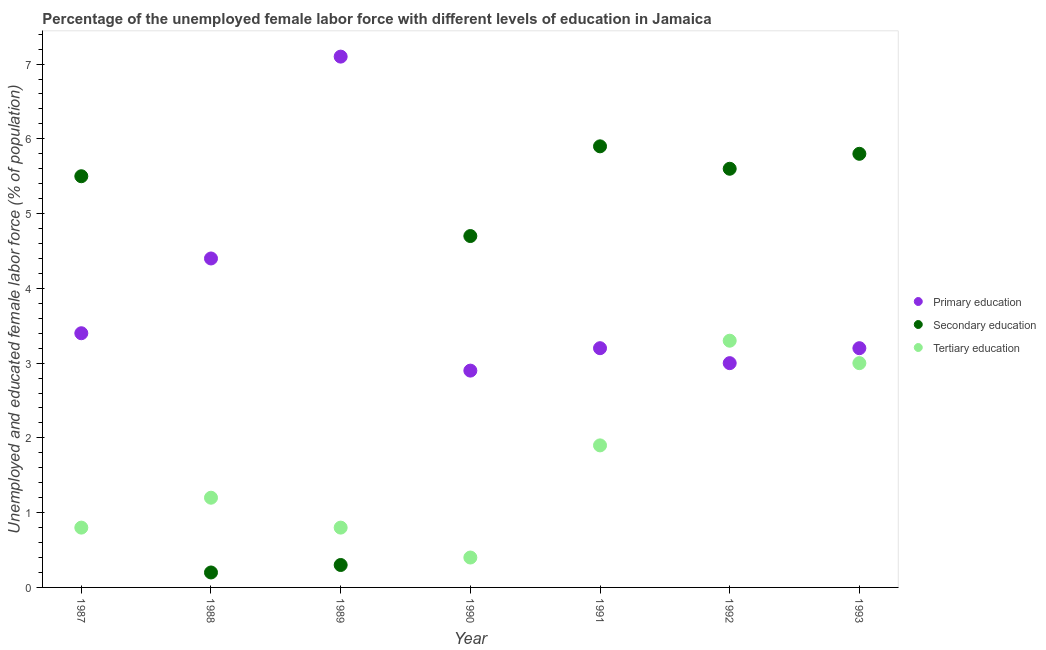How many different coloured dotlines are there?
Provide a short and direct response. 3. What is the percentage of female labor force who received tertiary education in 1992?
Your response must be concise. 3.3. Across all years, what is the maximum percentage of female labor force who received secondary education?
Your answer should be compact. 5.9. Across all years, what is the minimum percentage of female labor force who received primary education?
Provide a short and direct response. 2.9. What is the total percentage of female labor force who received tertiary education in the graph?
Make the answer very short. 11.4. What is the difference between the percentage of female labor force who received primary education in 1988 and that in 1989?
Keep it short and to the point. -2.7. What is the difference between the percentage of female labor force who received primary education in 1990 and the percentage of female labor force who received tertiary education in 1992?
Give a very brief answer. -0.4. What is the average percentage of female labor force who received primary education per year?
Your answer should be very brief. 3.89. In the year 1990, what is the difference between the percentage of female labor force who received primary education and percentage of female labor force who received secondary education?
Provide a succinct answer. -1.8. In how many years, is the percentage of female labor force who received primary education greater than 1.6 %?
Ensure brevity in your answer.  7. What is the ratio of the percentage of female labor force who received secondary education in 1988 to that in 1993?
Your answer should be compact. 0.03. What is the difference between the highest and the second highest percentage of female labor force who received secondary education?
Provide a short and direct response. 0.1. What is the difference between the highest and the lowest percentage of female labor force who received tertiary education?
Offer a very short reply. 2.9. Is it the case that in every year, the sum of the percentage of female labor force who received primary education and percentage of female labor force who received secondary education is greater than the percentage of female labor force who received tertiary education?
Offer a very short reply. Yes. Does the percentage of female labor force who received tertiary education monotonically increase over the years?
Keep it short and to the point. No. Is the percentage of female labor force who received secondary education strictly greater than the percentage of female labor force who received primary education over the years?
Provide a short and direct response. No. How many dotlines are there?
Your answer should be very brief. 3. Are the values on the major ticks of Y-axis written in scientific E-notation?
Keep it short and to the point. No. Where does the legend appear in the graph?
Provide a short and direct response. Center right. How many legend labels are there?
Your answer should be very brief. 3. How are the legend labels stacked?
Your answer should be compact. Vertical. What is the title of the graph?
Your answer should be compact. Percentage of the unemployed female labor force with different levels of education in Jamaica. Does "Agricultural raw materials" appear as one of the legend labels in the graph?
Ensure brevity in your answer.  No. What is the label or title of the X-axis?
Make the answer very short. Year. What is the label or title of the Y-axis?
Provide a short and direct response. Unemployed and educated female labor force (% of population). What is the Unemployed and educated female labor force (% of population) of Primary education in 1987?
Make the answer very short. 3.4. What is the Unemployed and educated female labor force (% of population) in Secondary education in 1987?
Offer a very short reply. 5.5. What is the Unemployed and educated female labor force (% of population) of Tertiary education in 1987?
Provide a short and direct response. 0.8. What is the Unemployed and educated female labor force (% of population) of Primary education in 1988?
Provide a short and direct response. 4.4. What is the Unemployed and educated female labor force (% of population) in Secondary education in 1988?
Provide a succinct answer. 0.2. What is the Unemployed and educated female labor force (% of population) of Tertiary education in 1988?
Ensure brevity in your answer.  1.2. What is the Unemployed and educated female labor force (% of population) in Primary education in 1989?
Give a very brief answer. 7.1. What is the Unemployed and educated female labor force (% of population) of Secondary education in 1989?
Your answer should be compact. 0.3. What is the Unemployed and educated female labor force (% of population) in Tertiary education in 1989?
Make the answer very short. 0.8. What is the Unemployed and educated female labor force (% of population) in Primary education in 1990?
Ensure brevity in your answer.  2.9. What is the Unemployed and educated female labor force (% of population) of Secondary education in 1990?
Offer a terse response. 4.7. What is the Unemployed and educated female labor force (% of population) of Tertiary education in 1990?
Offer a terse response. 0.4. What is the Unemployed and educated female labor force (% of population) in Primary education in 1991?
Give a very brief answer. 3.2. What is the Unemployed and educated female labor force (% of population) of Secondary education in 1991?
Provide a succinct answer. 5.9. What is the Unemployed and educated female labor force (% of population) in Tertiary education in 1991?
Make the answer very short. 1.9. What is the Unemployed and educated female labor force (% of population) in Secondary education in 1992?
Provide a short and direct response. 5.6. What is the Unemployed and educated female labor force (% of population) in Tertiary education in 1992?
Your answer should be compact. 3.3. What is the Unemployed and educated female labor force (% of population) of Primary education in 1993?
Your answer should be very brief. 3.2. What is the Unemployed and educated female labor force (% of population) in Secondary education in 1993?
Your answer should be compact. 5.8. Across all years, what is the maximum Unemployed and educated female labor force (% of population) of Primary education?
Give a very brief answer. 7.1. Across all years, what is the maximum Unemployed and educated female labor force (% of population) in Secondary education?
Your answer should be very brief. 5.9. Across all years, what is the maximum Unemployed and educated female labor force (% of population) in Tertiary education?
Give a very brief answer. 3.3. Across all years, what is the minimum Unemployed and educated female labor force (% of population) of Primary education?
Your answer should be very brief. 2.9. Across all years, what is the minimum Unemployed and educated female labor force (% of population) in Secondary education?
Provide a succinct answer. 0.2. Across all years, what is the minimum Unemployed and educated female labor force (% of population) in Tertiary education?
Offer a terse response. 0.4. What is the total Unemployed and educated female labor force (% of population) of Primary education in the graph?
Make the answer very short. 27.2. What is the total Unemployed and educated female labor force (% of population) of Secondary education in the graph?
Make the answer very short. 28. What is the total Unemployed and educated female labor force (% of population) of Tertiary education in the graph?
Your answer should be compact. 11.4. What is the difference between the Unemployed and educated female labor force (% of population) of Primary education in 1987 and that in 1988?
Provide a succinct answer. -1. What is the difference between the Unemployed and educated female labor force (% of population) in Primary education in 1987 and that in 1989?
Provide a succinct answer. -3.7. What is the difference between the Unemployed and educated female labor force (% of population) in Secondary education in 1987 and that in 1989?
Provide a succinct answer. 5.2. What is the difference between the Unemployed and educated female labor force (% of population) of Tertiary education in 1987 and that in 1989?
Give a very brief answer. 0. What is the difference between the Unemployed and educated female labor force (% of population) of Tertiary education in 1987 and that in 1990?
Your answer should be very brief. 0.4. What is the difference between the Unemployed and educated female labor force (% of population) of Primary education in 1987 and that in 1991?
Give a very brief answer. 0.2. What is the difference between the Unemployed and educated female labor force (% of population) of Secondary education in 1987 and that in 1992?
Your answer should be compact. -0.1. What is the difference between the Unemployed and educated female labor force (% of population) in Tertiary education in 1987 and that in 1992?
Keep it short and to the point. -2.5. What is the difference between the Unemployed and educated female labor force (% of population) of Primary education in 1987 and that in 1993?
Your answer should be compact. 0.2. What is the difference between the Unemployed and educated female labor force (% of population) of Primary education in 1988 and that in 1989?
Offer a terse response. -2.7. What is the difference between the Unemployed and educated female labor force (% of population) in Tertiary education in 1988 and that in 1989?
Your answer should be compact. 0.4. What is the difference between the Unemployed and educated female labor force (% of population) of Primary education in 1988 and that in 1991?
Ensure brevity in your answer.  1.2. What is the difference between the Unemployed and educated female labor force (% of population) in Secondary education in 1988 and that in 1991?
Ensure brevity in your answer.  -5.7. What is the difference between the Unemployed and educated female labor force (% of population) in Primary education in 1988 and that in 1992?
Your answer should be compact. 1.4. What is the difference between the Unemployed and educated female labor force (% of population) in Secondary education in 1988 and that in 1992?
Your response must be concise. -5.4. What is the difference between the Unemployed and educated female labor force (% of population) in Secondary education in 1988 and that in 1993?
Offer a terse response. -5.6. What is the difference between the Unemployed and educated female labor force (% of population) of Tertiary education in 1988 and that in 1993?
Your answer should be compact. -1.8. What is the difference between the Unemployed and educated female labor force (% of population) in Primary education in 1989 and that in 1990?
Make the answer very short. 4.2. What is the difference between the Unemployed and educated female labor force (% of population) of Secondary education in 1989 and that in 1990?
Provide a short and direct response. -4.4. What is the difference between the Unemployed and educated female labor force (% of population) in Primary education in 1989 and that in 1991?
Provide a succinct answer. 3.9. What is the difference between the Unemployed and educated female labor force (% of population) in Primary education in 1989 and that in 1992?
Ensure brevity in your answer.  4.1. What is the difference between the Unemployed and educated female labor force (% of population) in Secondary education in 1989 and that in 1993?
Ensure brevity in your answer.  -5.5. What is the difference between the Unemployed and educated female labor force (% of population) in Tertiary education in 1989 and that in 1993?
Give a very brief answer. -2.2. What is the difference between the Unemployed and educated female labor force (% of population) of Secondary education in 1990 and that in 1991?
Your answer should be compact. -1.2. What is the difference between the Unemployed and educated female labor force (% of population) of Primary education in 1990 and that in 1992?
Offer a very short reply. -0.1. What is the difference between the Unemployed and educated female labor force (% of population) in Secondary education in 1990 and that in 1992?
Offer a terse response. -0.9. What is the difference between the Unemployed and educated female labor force (% of population) of Tertiary education in 1990 and that in 1992?
Keep it short and to the point. -2.9. What is the difference between the Unemployed and educated female labor force (% of population) of Secondary education in 1990 and that in 1993?
Offer a terse response. -1.1. What is the difference between the Unemployed and educated female labor force (% of population) of Primary education in 1991 and that in 1992?
Offer a very short reply. 0.2. What is the difference between the Unemployed and educated female labor force (% of population) of Tertiary education in 1991 and that in 1992?
Your answer should be compact. -1.4. What is the difference between the Unemployed and educated female labor force (% of population) of Tertiary education in 1991 and that in 1993?
Give a very brief answer. -1.1. What is the difference between the Unemployed and educated female labor force (% of population) of Primary education in 1992 and that in 1993?
Offer a terse response. -0.2. What is the difference between the Unemployed and educated female labor force (% of population) of Secondary education in 1992 and that in 1993?
Provide a short and direct response. -0.2. What is the difference between the Unemployed and educated female labor force (% of population) in Primary education in 1987 and the Unemployed and educated female labor force (% of population) in Tertiary education in 1988?
Ensure brevity in your answer.  2.2. What is the difference between the Unemployed and educated female labor force (% of population) of Primary education in 1987 and the Unemployed and educated female labor force (% of population) of Tertiary education in 1989?
Offer a terse response. 2.6. What is the difference between the Unemployed and educated female labor force (% of population) of Secondary education in 1987 and the Unemployed and educated female labor force (% of population) of Tertiary education in 1989?
Offer a terse response. 4.7. What is the difference between the Unemployed and educated female labor force (% of population) of Primary education in 1987 and the Unemployed and educated female labor force (% of population) of Tertiary education in 1990?
Give a very brief answer. 3. What is the difference between the Unemployed and educated female labor force (% of population) of Primary education in 1987 and the Unemployed and educated female labor force (% of population) of Secondary education in 1991?
Your answer should be compact. -2.5. What is the difference between the Unemployed and educated female labor force (% of population) in Primary education in 1987 and the Unemployed and educated female labor force (% of population) in Secondary education in 1993?
Your answer should be compact. -2.4. What is the difference between the Unemployed and educated female labor force (% of population) in Primary education in 1987 and the Unemployed and educated female labor force (% of population) in Tertiary education in 1993?
Keep it short and to the point. 0.4. What is the difference between the Unemployed and educated female labor force (% of population) of Secondary education in 1987 and the Unemployed and educated female labor force (% of population) of Tertiary education in 1993?
Give a very brief answer. 2.5. What is the difference between the Unemployed and educated female labor force (% of population) in Primary education in 1988 and the Unemployed and educated female labor force (% of population) in Secondary education in 1989?
Offer a very short reply. 4.1. What is the difference between the Unemployed and educated female labor force (% of population) of Primary education in 1988 and the Unemployed and educated female labor force (% of population) of Tertiary education in 1990?
Keep it short and to the point. 4. What is the difference between the Unemployed and educated female labor force (% of population) of Secondary education in 1988 and the Unemployed and educated female labor force (% of population) of Tertiary education in 1990?
Offer a very short reply. -0.2. What is the difference between the Unemployed and educated female labor force (% of population) in Primary education in 1988 and the Unemployed and educated female labor force (% of population) in Secondary education in 1991?
Provide a short and direct response. -1.5. What is the difference between the Unemployed and educated female labor force (% of population) in Secondary education in 1988 and the Unemployed and educated female labor force (% of population) in Tertiary education in 1991?
Your response must be concise. -1.7. What is the difference between the Unemployed and educated female labor force (% of population) of Primary education in 1988 and the Unemployed and educated female labor force (% of population) of Secondary education in 1992?
Offer a very short reply. -1.2. What is the difference between the Unemployed and educated female labor force (% of population) in Primary education in 1988 and the Unemployed and educated female labor force (% of population) in Tertiary education in 1992?
Offer a very short reply. 1.1. What is the difference between the Unemployed and educated female labor force (% of population) of Secondary education in 1988 and the Unemployed and educated female labor force (% of population) of Tertiary education in 1992?
Keep it short and to the point. -3.1. What is the difference between the Unemployed and educated female labor force (% of population) in Primary education in 1988 and the Unemployed and educated female labor force (% of population) in Secondary education in 1993?
Give a very brief answer. -1.4. What is the difference between the Unemployed and educated female labor force (% of population) in Primary education in 1988 and the Unemployed and educated female labor force (% of population) in Tertiary education in 1993?
Give a very brief answer. 1.4. What is the difference between the Unemployed and educated female labor force (% of population) of Primary education in 1989 and the Unemployed and educated female labor force (% of population) of Secondary education in 1990?
Offer a terse response. 2.4. What is the difference between the Unemployed and educated female labor force (% of population) in Primary education in 1989 and the Unemployed and educated female labor force (% of population) in Tertiary education in 1990?
Provide a short and direct response. 6.7. What is the difference between the Unemployed and educated female labor force (% of population) of Secondary education in 1989 and the Unemployed and educated female labor force (% of population) of Tertiary education in 1990?
Your answer should be compact. -0.1. What is the difference between the Unemployed and educated female labor force (% of population) of Primary education in 1989 and the Unemployed and educated female labor force (% of population) of Secondary education in 1991?
Offer a terse response. 1.2. What is the difference between the Unemployed and educated female labor force (% of population) of Primary education in 1989 and the Unemployed and educated female labor force (% of population) of Tertiary education in 1991?
Offer a terse response. 5.2. What is the difference between the Unemployed and educated female labor force (% of population) of Secondary education in 1989 and the Unemployed and educated female labor force (% of population) of Tertiary education in 1991?
Your answer should be compact. -1.6. What is the difference between the Unemployed and educated female labor force (% of population) in Primary education in 1989 and the Unemployed and educated female labor force (% of population) in Secondary education in 1992?
Your response must be concise. 1.5. What is the difference between the Unemployed and educated female labor force (% of population) in Secondary education in 1989 and the Unemployed and educated female labor force (% of population) in Tertiary education in 1992?
Offer a terse response. -3. What is the difference between the Unemployed and educated female labor force (% of population) of Primary education in 1990 and the Unemployed and educated female labor force (% of population) of Secondary education in 1991?
Your response must be concise. -3. What is the difference between the Unemployed and educated female labor force (% of population) in Primary education in 1990 and the Unemployed and educated female labor force (% of population) in Tertiary education in 1991?
Ensure brevity in your answer.  1. What is the difference between the Unemployed and educated female labor force (% of population) of Primary education in 1990 and the Unemployed and educated female labor force (% of population) of Secondary education in 1992?
Your response must be concise. -2.7. What is the difference between the Unemployed and educated female labor force (% of population) of Primary education in 1990 and the Unemployed and educated female labor force (% of population) of Tertiary education in 1992?
Your answer should be very brief. -0.4. What is the difference between the Unemployed and educated female labor force (% of population) in Secondary education in 1990 and the Unemployed and educated female labor force (% of population) in Tertiary education in 1992?
Your response must be concise. 1.4. What is the difference between the Unemployed and educated female labor force (% of population) in Primary education in 1990 and the Unemployed and educated female labor force (% of population) in Tertiary education in 1993?
Ensure brevity in your answer.  -0.1. What is the difference between the Unemployed and educated female labor force (% of population) of Secondary education in 1990 and the Unemployed and educated female labor force (% of population) of Tertiary education in 1993?
Provide a succinct answer. 1.7. What is the difference between the Unemployed and educated female labor force (% of population) in Primary education in 1991 and the Unemployed and educated female labor force (% of population) in Tertiary education in 1992?
Make the answer very short. -0.1. What is the difference between the Unemployed and educated female labor force (% of population) in Primary education in 1991 and the Unemployed and educated female labor force (% of population) in Tertiary education in 1993?
Keep it short and to the point. 0.2. What is the difference between the Unemployed and educated female labor force (% of population) in Primary education in 1992 and the Unemployed and educated female labor force (% of population) in Tertiary education in 1993?
Give a very brief answer. 0. What is the difference between the Unemployed and educated female labor force (% of population) of Secondary education in 1992 and the Unemployed and educated female labor force (% of population) of Tertiary education in 1993?
Make the answer very short. 2.6. What is the average Unemployed and educated female labor force (% of population) of Primary education per year?
Offer a terse response. 3.89. What is the average Unemployed and educated female labor force (% of population) in Secondary education per year?
Offer a very short reply. 4. What is the average Unemployed and educated female labor force (% of population) of Tertiary education per year?
Offer a very short reply. 1.63. In the year 1987, what is the difference between the Unemployed and educated female labor force (% of population) in Secondary education and Unemployed and educated female labor force (% of population) in Tertiary education?
Keep it short and to the point. 4.7. In the year 1988, what is the difference between the Unemployed and educated female labor force (% of population) of Primary education and Unemployed and educated female labor force (% of population) of Tertiary education?
Provide a short and direct response. 3.2. In the year 1989, what is the difference between the Unemployed and educated female labor force (% of population) of Primary education and Unemployed and educated female labor force (% of population) of Secondary education?
Provide a short and direct response. 6.8. In the year 1990, what is the difference between the Unemployed and educated female labor force (% of population) of Primary education and Unemployed and educated female labor force (% of population) of Tertiary education?
Your answer should be very brief. 2.5. In the year 1990, what is the difference between the Unemployed and educated female labor force (% of population) in Secondary education and Unemployed and educated female labor force (% of population) in Tertiary education?
Your response must be concise. 4.3. In the year 1991, what is the difference between the Unemployed and educated female labor force (% of population) in Primary education and Unemployed and educated female labor force (% of population) in Secondary education?
Your response must be concise. -2.7. In the year 1991, what is the difference between the Unemployed and educated female labor force (% of population) in Primary education and Unemployed and educated female labor force (% of population) in Tertiary education?
Ensure brevity in your answer.  1.3. In the year 1992, what is the difference between the Unemployed and educated female labor force (% of population) in Primary education and Unemployed and educated female labor force (% of population) in Secondary education?
Your answer should be compact. -2.6. In the year 1992, what is the difference between the Unemployed and educated female labor force (% of population) of Primary education and Unemployed and educated female labor force (% of population) of Tertiary education?
Provide a short and direct response. -0.3. In the year 1993, what is the difference between the Unemployed and educated female labor force (% of population) in Primary education and Unemployed and educated female labor force (% of population) in Secondary education?
Your response must be concise. -2.6. In the year 1993, what is the difference between the Unemployed and educated female labor force (% of population) in Secondary education and Unemployed and educated female labor force (% of population) in Tertiary education?
Your answer should be compact. 2.8. What is the ratio of the Unemployed and educated female labor force (% of population) in Primary education in 1987 to that in 1988?
Ensure brevity in your answer.  0.77. What is the ratio of the Unemployed and educated female labor force (% of population) of Secondary education in 1987 to that in 1988?
Make the answer very short. 27.5. What is the ratio of the Unemployed and educated female labor force (% of population) in Tertiary education in 1987 to that in 1988?
Your answer should be very brief. 0.67. What is the ratio of the Unemployed and educated female labor force (% of population) in Primary education in 1987 to that in 1989?
Provide a succinct answer. 0.48. What is the ratio of the Unemployed and educated female labor force (% of population) of Secondary education in 1987 to that in 1989?
Your answer should be very brief. 18.33. What is the ratio of the Unemployed and educated female labor force (% of population) in Primary education in 1987 to that in 1990?
Your response must be concise. 1.17. What is the ratio of the Unemployed and educated female labor force (% of population) in Secondary education in 1987 to that in 1990?
Your answer should be compact. 1.17. What is the ratio of the Unemployed and educated female labor force (% of population) in Tertiary education in 1987 to that in 1990?
Give a very brief answer. 2. What is the ratio of the Unemployed and educated female labor force (% of population) in Secondary education in 1987 to that in 1991?
Make the answer very short. 0.93. What is the ratio of the Unemployed and educated female labor force (% of population) in Tertiary education in 1987 to that in 1991?
Provide a succinct answer. 0.42. What is the ratio of the Unemployed and educated female labor force (% of population) of Primary education in 1987 to that in 1992?
Ensure brevity in your answer.  1.13. What is the ratio of the Unemployed and educated female labor force (% of population) in Secondary education in 1987 to that in 1992?
Offer a terse response. 0.98. What is the ratio of the Unemployed and educated female labor force (% of population) in Tertiary education in 1987 to that in 1992?
Your answer should be compact. 0.24. What is the ratio of the Unemployed and educated female labor force (% of population) of Primary education in 1987 to that in 1993?
Keep it short and to the point. 1.06. What is the ratio of the Unemployed and educated female labor force (% of population) in Secondary education in 1987 to that in 1993?
Make the answer very short. 0.95. What is the ratio of the Unemployed and educated female labor force (% of population) in Tertiary education in 1987 to that in 1993?
Ensure brevity in your answer.  0.27. What is the ratio of the Unemployed and educated female labor force (% of population) in Primary education in 1988 to that in 1989?
Your answer should be very brief. 0.62. What is the ratio of the Unemployed and educated female labor force (% of population) of Secondary education in 1988 to that in 1989?
Your answer should be very brief. 0.67. What is the ratio of the Unemployed and educated female labor force (% of population) of Primary education in 1988 to that in 1990?
Your answer should be very brief. 1.52. What is the ratio of the Unemployed and educated female labor force (% of population) of Secondary education in 1988 to that in 1990?
Your answer should be very brief. 0.04. What is the ratio of the Unemployed and educated female labor force (% of population) in Tertiary education in 1988 to that in 1990?
Your answer should be very brief. 3. What is the ratio of the Unemployed and educated female labor force (% of population) of Primary education in 1988 to that in 1991?
Offer a terse response. 1.38. What is the ratio of the Unemployed and educated female labor force (% of population) in Secondary education in 1988 to that in 1991?
Your response must be concise. 0.03. What is the ratio of the Unemployed and educated female labor force (% of population) of Tertiary education in 1988 to that in 1991?
Make the answer very short. 0.63. What is the ratio of the Unemployed and educated female labor force (% of population) of Primary education in 1988 to that in 1992?
Provide a short and direct response. 1.47. What is the ratio of the Unemployed and educated female labor force (% of population) in Secondary education in 1988 to that in 1992?
Your answer should be compact. 0.04. What is the ratio of the Unemployed and educated female labor force (% of population) in Tertiary education in 1988 to that in 1992?
Make the answer very short. 0.36. What is the ratio of the Unemployed and educated female labor force (% of population) in Primary education in 1988 to that in 1993?
Ensure brevity in your answer.  1.38. What is the ratio of the Unemployed and educated female labor force (% of population) of Secondary education in 1988 to that in 1993?
Ensure brevity in your answer.  0.03. What is the ratio of the Unemployed and educated female labor force (% of population) of Tertiary education in 1988 to that in 1993?
Offer a very short reply. 0.4. What is the ratio of the Unemployed and educated female labor force (% of population) in Primary education in 1989 to that in 1990?
Offer a terse response. 2.45. What is the ratio of the Unemployed and educated female labor force (% of population) of Secondary education in 1989 to that in 1990?
Give a very brief answer. 0.06. What is the ratio of the Unemployed and educated female labor force (% of population) of Primary education in 1989 to that in 1991?
Ensure brevity in your answer.  2.22. What is the ratio of the Unemployed and educated female labor force (% of population) of Secondary education in 1989 to that in 1991?
Provide a short and direct response. 0.05. What is the ratio of the Unemployed and educated female labor force (% of population) of Tertiary education in 1989 to that in 1991?
Offer a terse response. 0.42. What is the ratio of the Unemployed and educated female labor force (% of population) in Primary education in 1989 to that in 1992?
Provide a short and direct response. 2.37. What is the ratio of the Unemployed and educated female labor force (% of population) in Secondary education in 1989 to that in 1992?
Offer a very short reply. 0.05. What is the ratio of the Unemployed and educated female labor force (% of population) in Tertiary education in 1989 to that in 1992?
Your answer should be compact. 0.24. What is the ratio of the Unemployed and educated female labor force (% of population) in Primary education in 1989 to that in 1993?
Offer a very short reply. 2.22. What is the ratio of the Unemployed and educated female labor force (% of population) of Secondary education in 1989 to that in 1993?
Keep it short and to the point. 0.05. What is the ratio of the Unemployed and educated female labor force (% of population) of Tertiary education in 1989 to that in 1993?
Make the answer very short. 0.27. What is the ratio of the Unemployed and educated female labor force (% of population) of Primary education in 1990 to that in 1991?
Provide a short and direct response. 0.91. What is the ratio of the Unemployed and educated female labor force (% of population) of Secondary education in 1990 to that in 1991?
Make the answer very short. 0.8. What is the ratio of the Unemployed and educated female labor force (% of population) in Tertiary education in 1990 to that in 1991?
Provide a short and direct response. 0.21. What is the ratio of the Unemployed and educated female labor force (% of population) of Primary education in 1990 to that in 1992?
Your response must be concise. 0.97. What is the ratio of the Unemployed and educated female labor force (% of population) of Secondary education in 1990 to that in 1992?
Provide a succinct answer. 0.84. What is the ratio of the Unemployed and educated female labor force (% of population) of Tertiary education in 1990 to that in 1992?
Make the answer very short. 0.12. What is the ratio of the Unemployed and educated female labor force (% of population) in Primary education in 1990 to that in 1993?
Provide a succinct answer. 0.91. What is the ratio of the Unemployed and educated female labor force (% of population) of Secondary education in 1990 to that in 1993?
Make the answer very short. 0.81. What is the ratio of the Unemployed and educated female labor force (% of population) of Tertiary education in 1990 to that in 1993?
Your answer should be very brief. 0.13. What is the ratio of the Unemployed and educated female labor force (% of population) in Primary education in 1991 to that in 1992?
Offer a terse response. 1.07. What is the ratio of the Unemployed and educated female labor force (% of population) of Secondary education in 1991 to that in 1992?
Give a very brief answer. 1.05. What is the ratio of the Unemployed and educated female labor force (% of population) of Tertiary education in 1991 to that in 1992?
Provide a succinct answer. 0.58. What is the ratio of the Unemployed and educated female labor force (% of population) of Secondary education in 1991 to that in 1993?
Provide a succinct answer. 1.02. What is the ratio of the Unemployed and educated female labor force (% of population) of Tertiary education in 1991 to that in 1993?
Ensure brevity in your answer.  0.63. What is the ratio of the Unemployed and educated female labor force (% of population) in Primary education in 1992 to that in 1993?
Your answer should be compact. 0.94. What is the ratio of the Unemployed and educated female labor force (% of population) of Secondary education in 1992 to that in 1993?
Keep it short and to the point. 0.97. What is the difference between the highest and the second highest Unemployed and educated female labor force (% of population) in Primary education?
Your answer should be compact. 2.7. What is the difference between the highest and the lowest Unemployed and educated female labor force (% of population) in Tertiary education?
Provide a short and direct response. 2.9. 